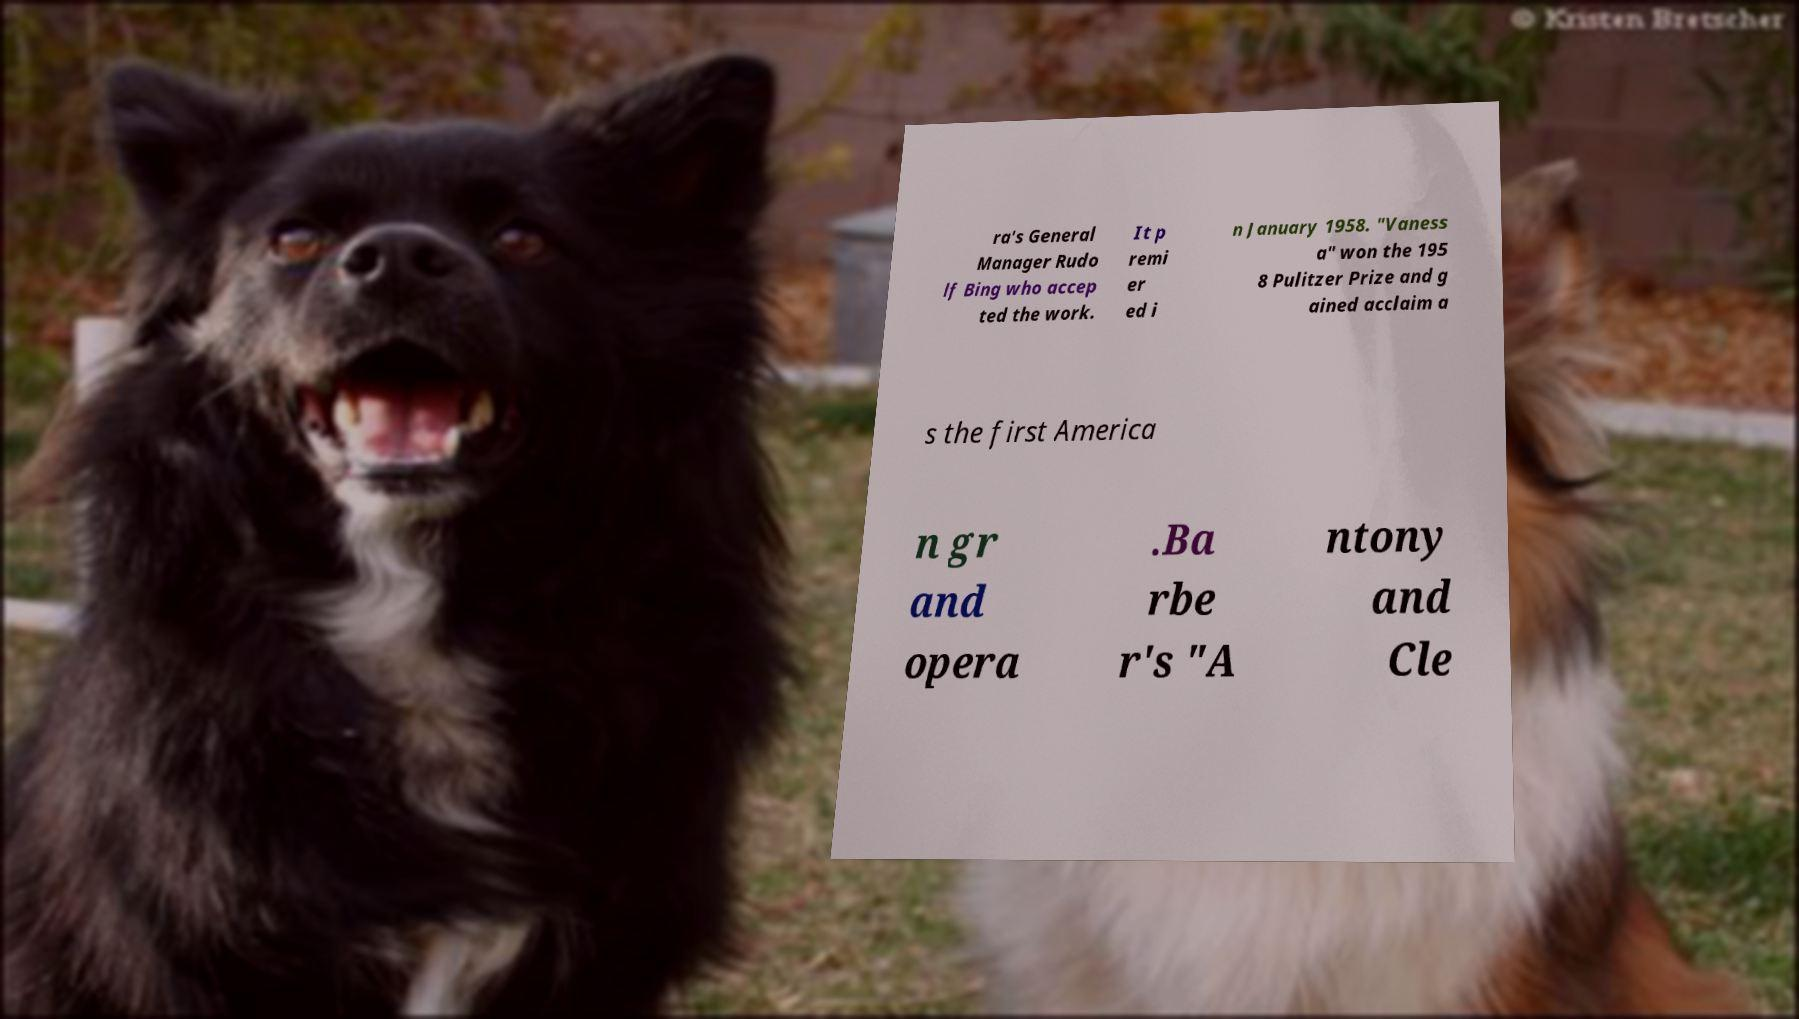What messages or text are displayed in this image? I need them in a readable, typed format. ra's General Manager Rudo lf Bing who accep ted the work. It p remi er ed i n January 1958. "Vaness a" won the 195 8 Pulitzer Prize and g ained acclaim a s the first America n gr and opera .Ba rbe r's "A ntony and Cle 